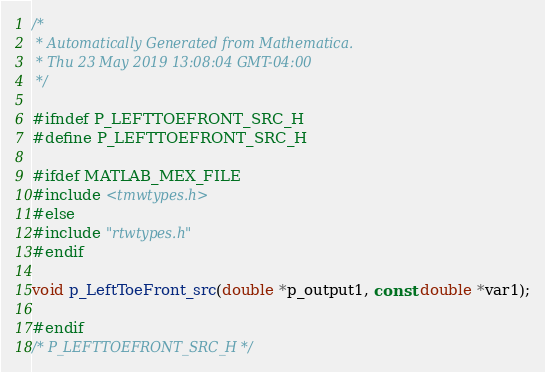<code> <loc_0><loc_0><loc_500><loc_500><_C_>/*
 * Automatically Generated from Mathematica.
 * Thu 23 May 2019 13:08:04 GMT-04:00
 */

#ifndef P_LEFTTOEFRONT_SRC_H
#define P_LEFTTOEFRONT_SRC_H

#ifdef MATLAB_MEX_FILE
#include <tmwtypes.h>
#else
#include "rtwtypes.h"
#endif

void p_LeftToeFront_src(double *p_output1, const double *var1);

#endif 
/* P_LEFTTOEFRONT_SRC_H */
</code> 